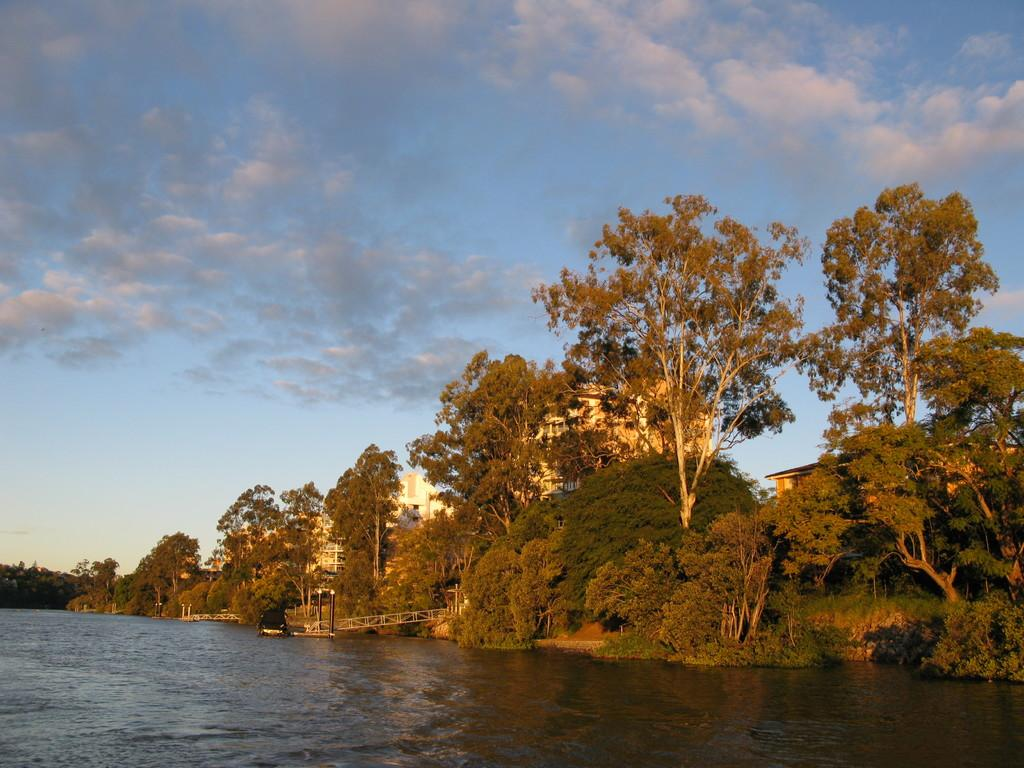What is the primary element visible in the image? There is water in the image. What other natural elements can be seen in the image? There are trees in the image. Are there any man-made structures visible? Yes, there are buildings in the image. What else can be seen in the image besides water, trees, and buildings? There are poles in the image. What is visible in the background of the image? The sky is visible in the background of the image, and clouds are present in the sky. How many frogs can be seen hopping in the water in the image? There are no frogs present in the image; it only features water, trees, buildings, poles, and a sky with clouds. What type of star can be seen shining in the sky in the image? There is no star visible in the image; only clouds are present in the sky. 